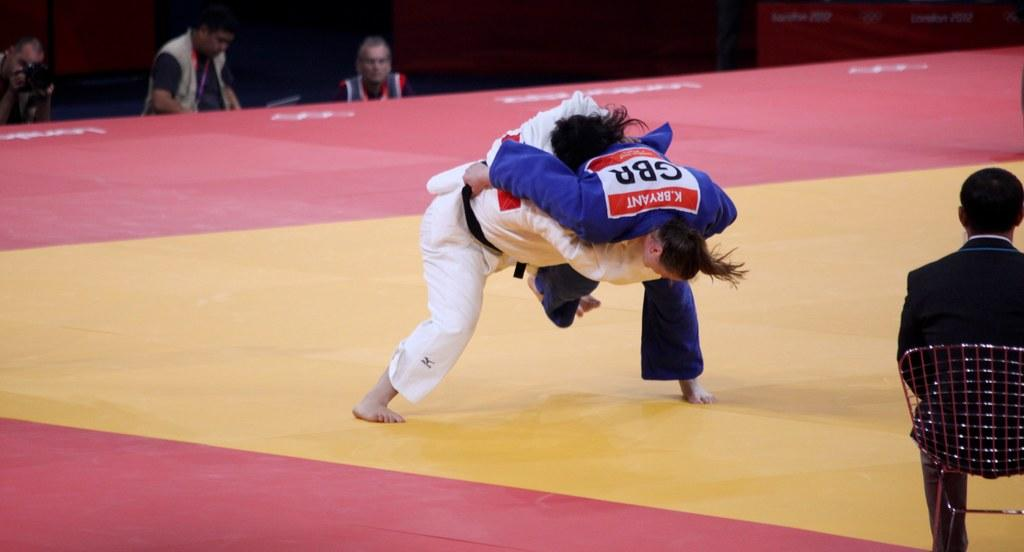<image>
Write a terse but informative summary of the picture. Two martial artists are grappled with one of them having the initials GBR on her back. 